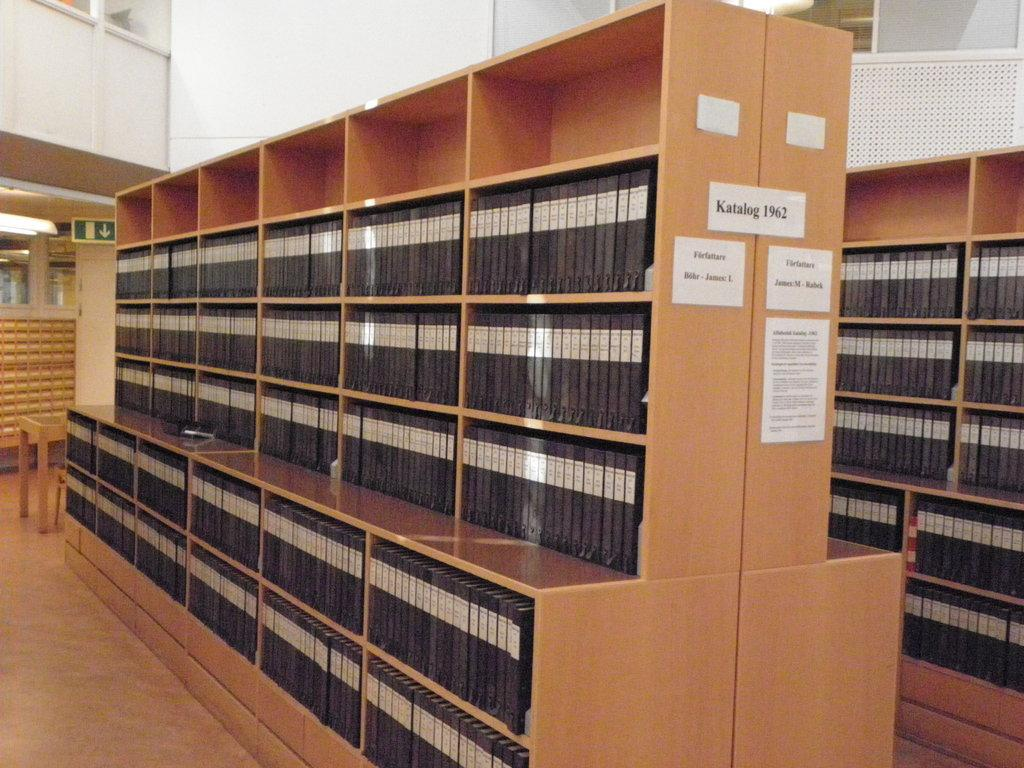<image>
Share a concise interpretation of the image provided. a brown case with the word katalog on it 